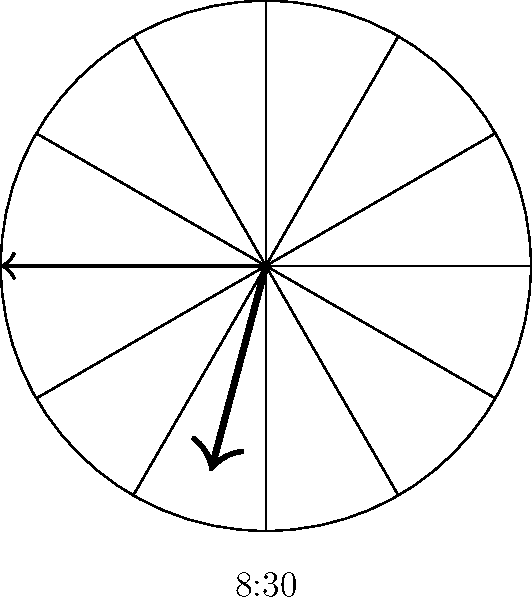In India, dinner is often served later than in many Western countries. If a typical Indian dinner time is shown on this clock, what is the approximate angle between the hour hand and the minute hand? Let's approach this step-by-step:

1. The clock shows 8:30, which is a common dinner time in India.

2. To find the angle between the hands, we need to calculate the position of each hand:

   - The hour hand: In 12 hours, it rotates 360°. So in 1 hour, it rotates 30°.
     At 8:30, it has rotated $8 * 30° + 30° * (30/60) = 240° + 15° = 255°$

   - The minute hand: In 60 minutes, it rotates 360°. So in 1 minute, it rotates 6°.
     At 30 minutes past, it has rotated $30 * 6° = 180°$

3. The angle between the hands is the absolute difference between these angles:
   $|255° - 180°| = 75°$

4. However, we always choose the smaller angle between the hands. The larger angle would be $360° - 75° = 285°$

Therefore, the angle between the hour hand and the minute hand at 8:30 is 75°.
Answer: 75° 